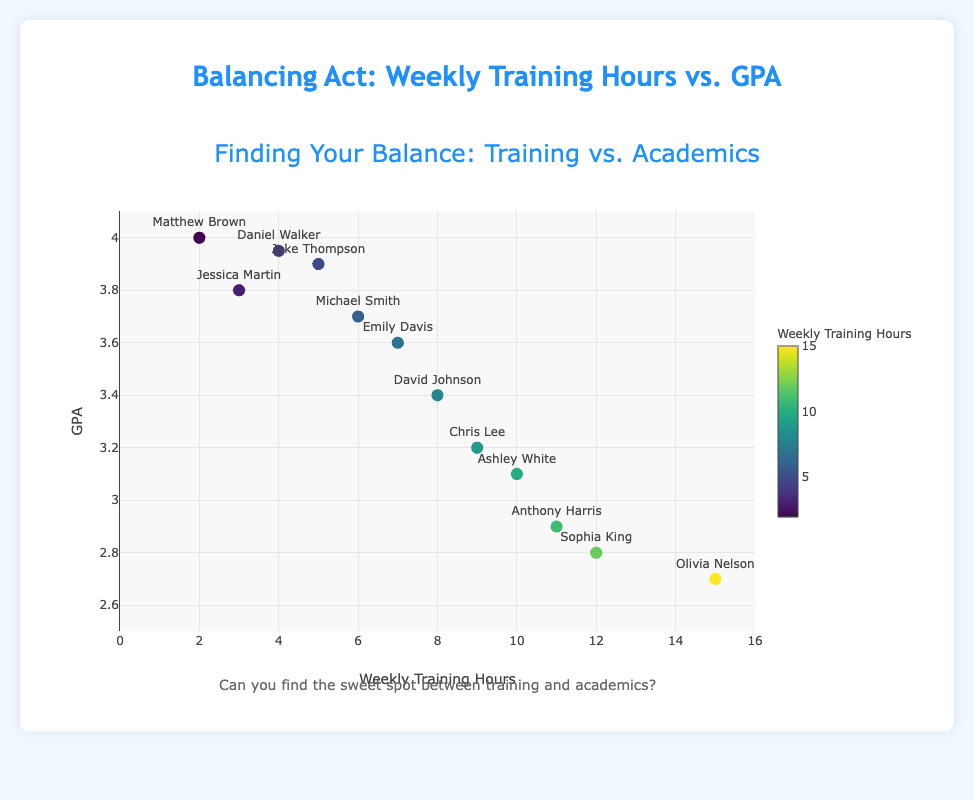What is the GPA of the player who trains the most weekly? Olivia Nelson trains the most weekly with 15 hours and her GPA is 2.7.
Answer: 2.7 Which player has the highest GPA, and how many hours do they train per week? Matthew Brown has the highest GPA of 4.0 and trains 2 hours per week.
Answer: Matthew Brown, 2 hours Is there a general trend between Weekly Training Hours and GPA? As the Weekly Training Hours increase, there seems to be a general decline in GPA based on the scatter plot trend.
Answer: Decline in GPA Who trains more, Michael Smith or Chris Lee, and what are their GPAs? Chris Lee trains more with 9 hours per week (GPA 3.2) compared to Michael Smith's 6 hours per week (GPA 3.7).
Answer: Chris Lee, 3.2 - Michael Smith, 3.7 What is the combined weekly training hours of the top two players with the highest GPAs? The top two players with the highest GPAs are Matthew Brown (4.0, 2 hours) and Daniel Walker (3.95, 4 hours). Their combined training hours are 2 + 4 = 6 hours.
Answer: 6 hours What color represents the player with the lowest GPA, and how many hours do they train per week? The player with the lowest GPA is Olivia Nelson with a GPA of 2.7. She trains for 15 hours weekly, represented by a darker color on the Viridis colorscale.
Answer: Darker color, 15 hours Is there any player who trains exactly 10 hours per week and what is their GPA? Yes, Ashley White trains exactly 10 hours per week and her GPA is 3.1.
Answer: Ashley White, 3.1 Calculate the average GPA of players training 8 or more hours per week. Players training 8 or more hours per week are David Johnson (3.4), Chris Lee (3.2), Ashley White (3.1), Anthony Harris (2.9), Sophia King (2.8), and Olivia Nelson (2.7). The average GPA is (3.4 + 3.2 + 3.1 + 2.9 + 2.8 + 2.7) / 6 = 3.02.
Answer: 3.02 Who has the lower GPA: Emily Davis or Anthony Harris, and by how much? Anthony Harris has a lower GPA (2.9) than Emily Davis (3.6). The difference is 3.6 - 2.9 = 0.7.
Answer: Anthony Harris, 0.7 Which player trains 5 hours per week and what is their GPA? Jake Thompson trains 5 hours per week and his GPA is 3.9.
Answer: Jake Thompson, 3.9 